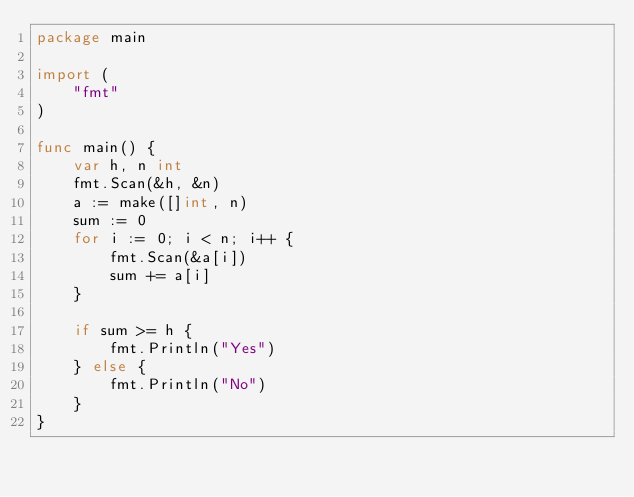<code> <loc_0><loc_0><loc_500><loc_500><_Go_>package main

import (
	"fmt"
)

func main() {
	var h, n int
	fmt.Scan(&h, &n)
	a := make([]int, n)
	sum := 0
	for i := 0; i < n; i++ {
		fmt.Scan(&a[i])
		sum += a[i]
	}

	if sum >= h {
		fmt.Println("Yes")
	} else {
		fmt.Println("No")
	}
}
</code> 